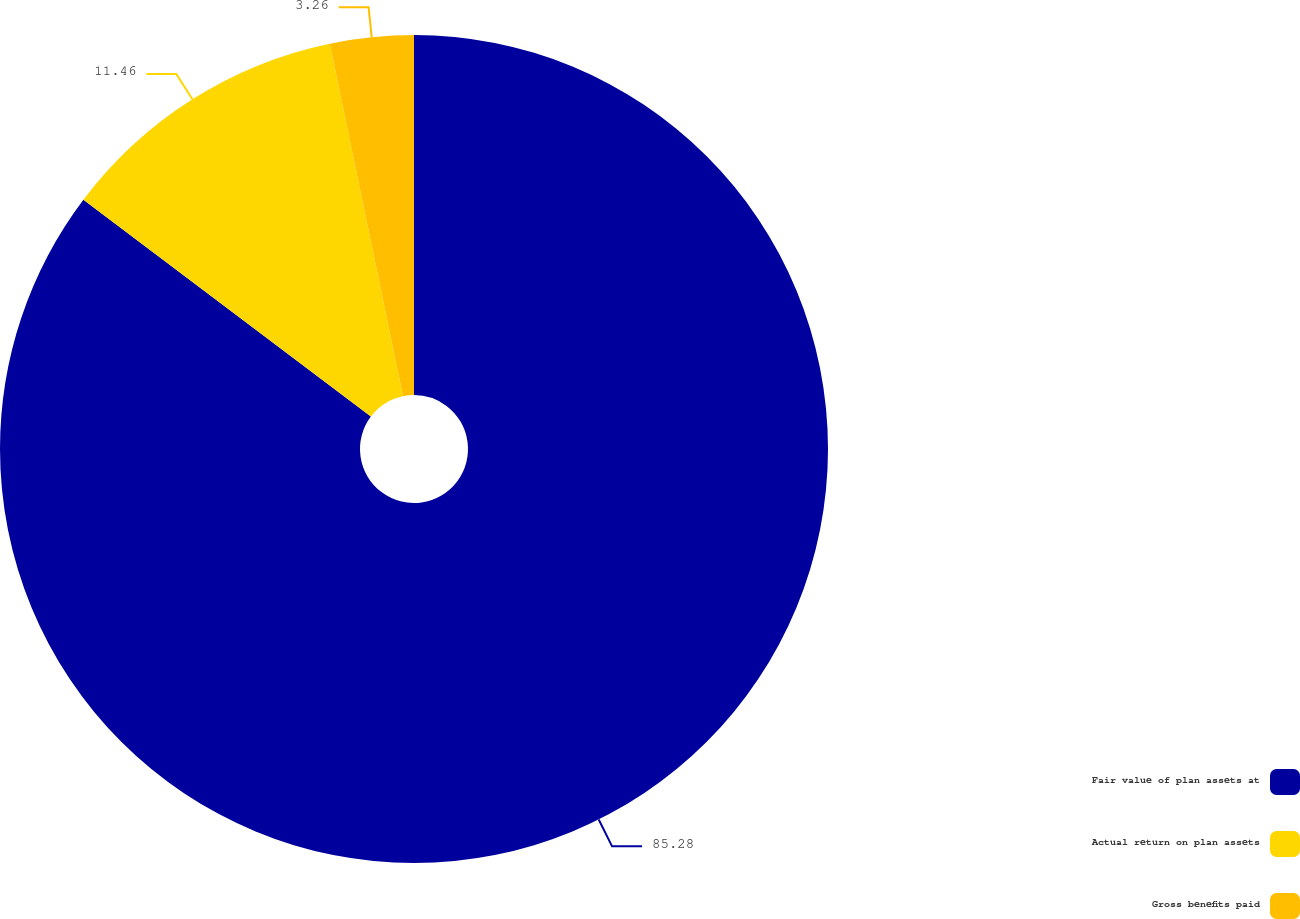Convert chart to OTSL. <chart><loc_0><loc_0><loc_500><loc_500><pie_chart><fcel>Fair value of plan assets at<fcel>Actual return on plan assets<fcel>Gross benefits paid<nl><fcel>85.28%<fcel>11.46%<fcel>3.26%<nl></chart> 